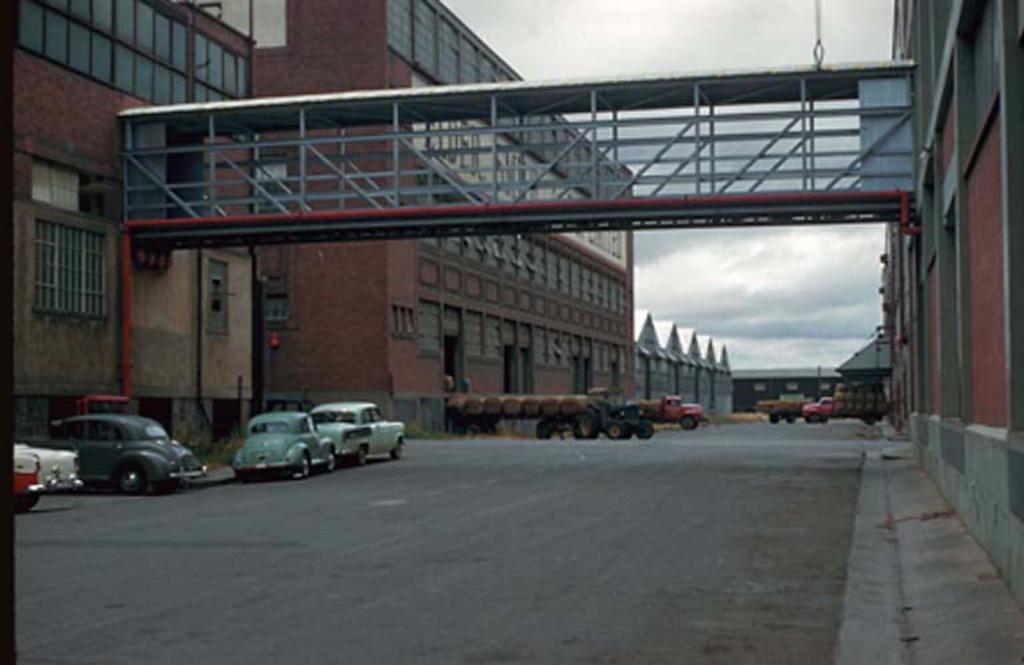Could you give a brief overview of what you see in this image? In this image I see a bridge over here and I see number of buildings and I see few vehicles and I see the road. In the background I see the sky which is cloudy. 